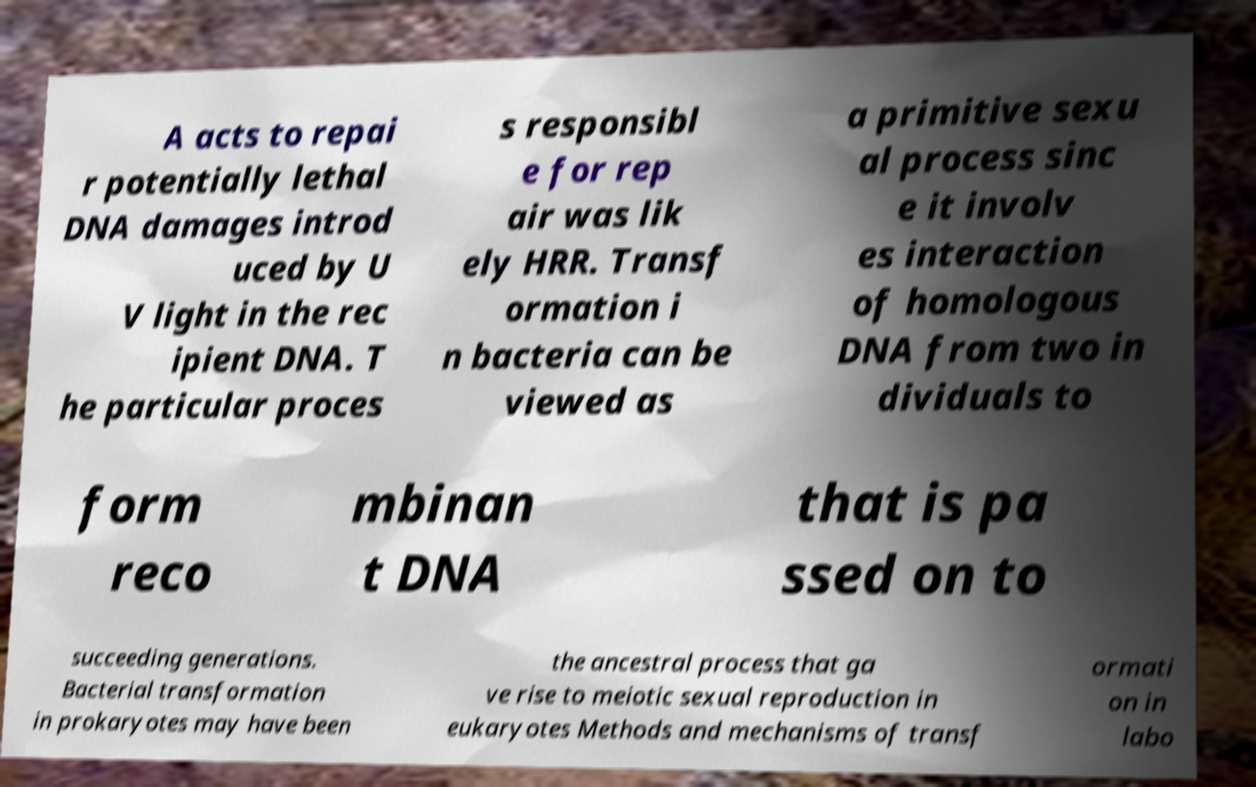Can you read and provide the text displayed in the image?This photo seems to have some interesting text. Can you extract and type it out for me? A acts to repai r potentially lethal DNA damages introd uced by U V light in the rec ipient DNA. T he particular proces s responsibl e for rep air was lik ely HRR. Transf ormation i n bacteria can be viewed as a primitive sexu al process sinc e it involv es interaction of homologous DNA from two in dividuals to form reco mbinan t DNA that is pa ssed on to succeeding generations. Bacterial transformation in prokaryotes may have been the ancestral process that ga ve rise to meiotic sexual reproduction in eukaryotes Methods and mechanisms of transf ormati on in labo 